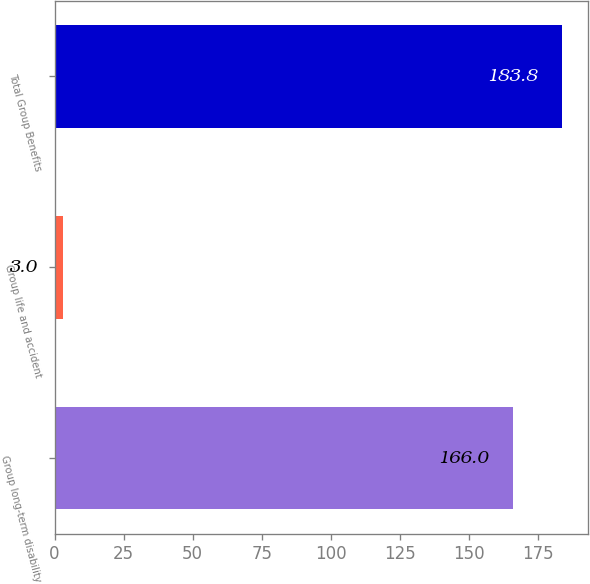<chart> <loc_0><loc_0><loc_500><loc_500><bar_chart><fcel>Group long-term disability<fcel>Group life and accident<fcel>Total Group Benefits<nl><fcel>166<fcel>3<fcel>183.8<nl></chart> 